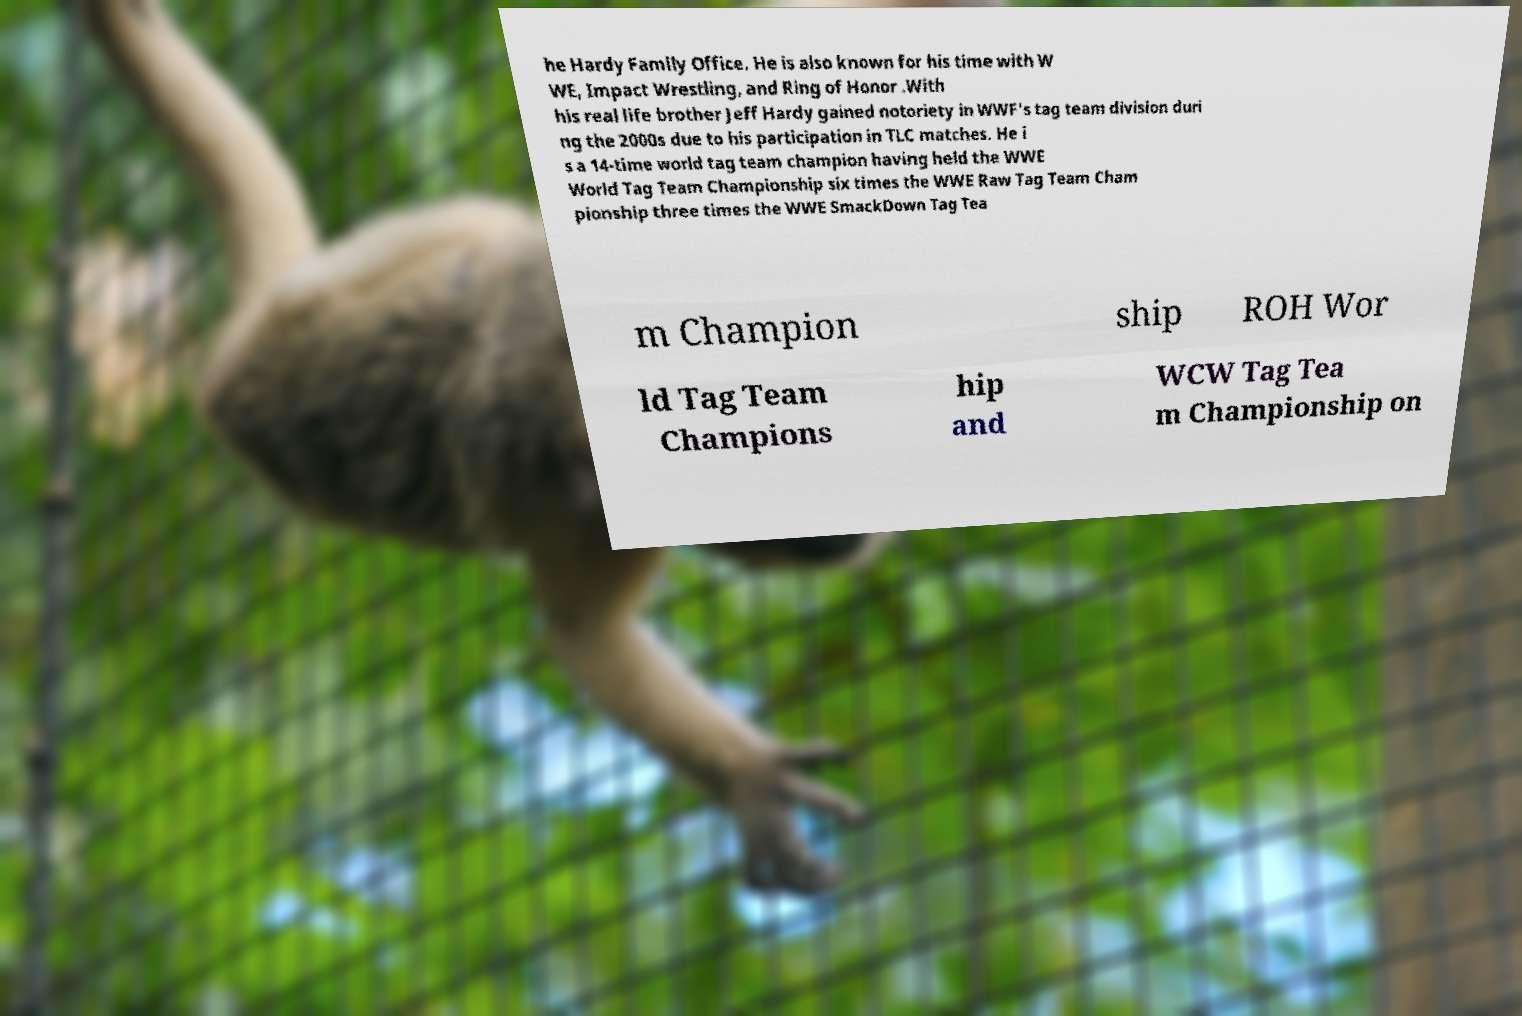Can you accurately transcribe the text from the provided image for me? he Hardy Family Office. He is also known for his time with W WE, Impact Wrestling, and Ring of Honor .With his real life brother Jeff Hardy gained notoriety in WWF's tag team division duri ng the 2000s due to his participation in TLC matches. He i s a 14-time world tag team champion having held the WWE World Tag Team Championship six times the WWE Raw Tag Team Cham pionship three times the WWE SmackDown Tag Tea m Champion ship ROH Wor ld Tag Team Champions hip and WCW Tag Tea m Championship on 